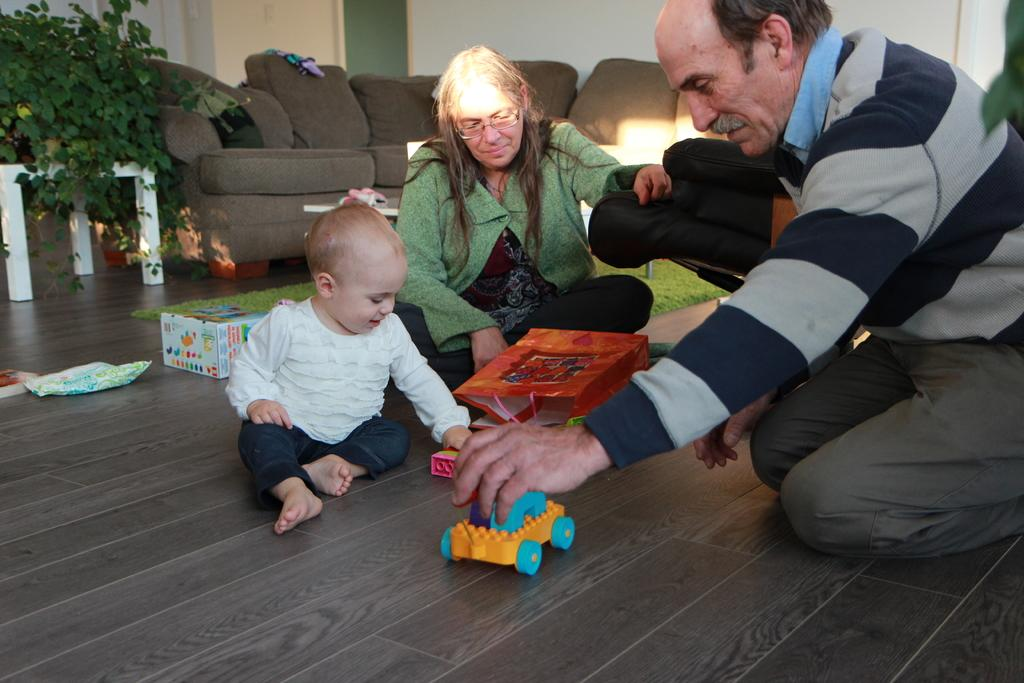Who or what can be seen in the image? There are people in the image. What is on the floor in the image? There are objects on the floor. Where is the plant located in the image? There is a plant on the left side of the image. What can be seen in the background of the image? There is a sofa and a wall in the background of the image. What type of stick can be seen in the position of the jar in the image? There is no stick or jar present in the image. 